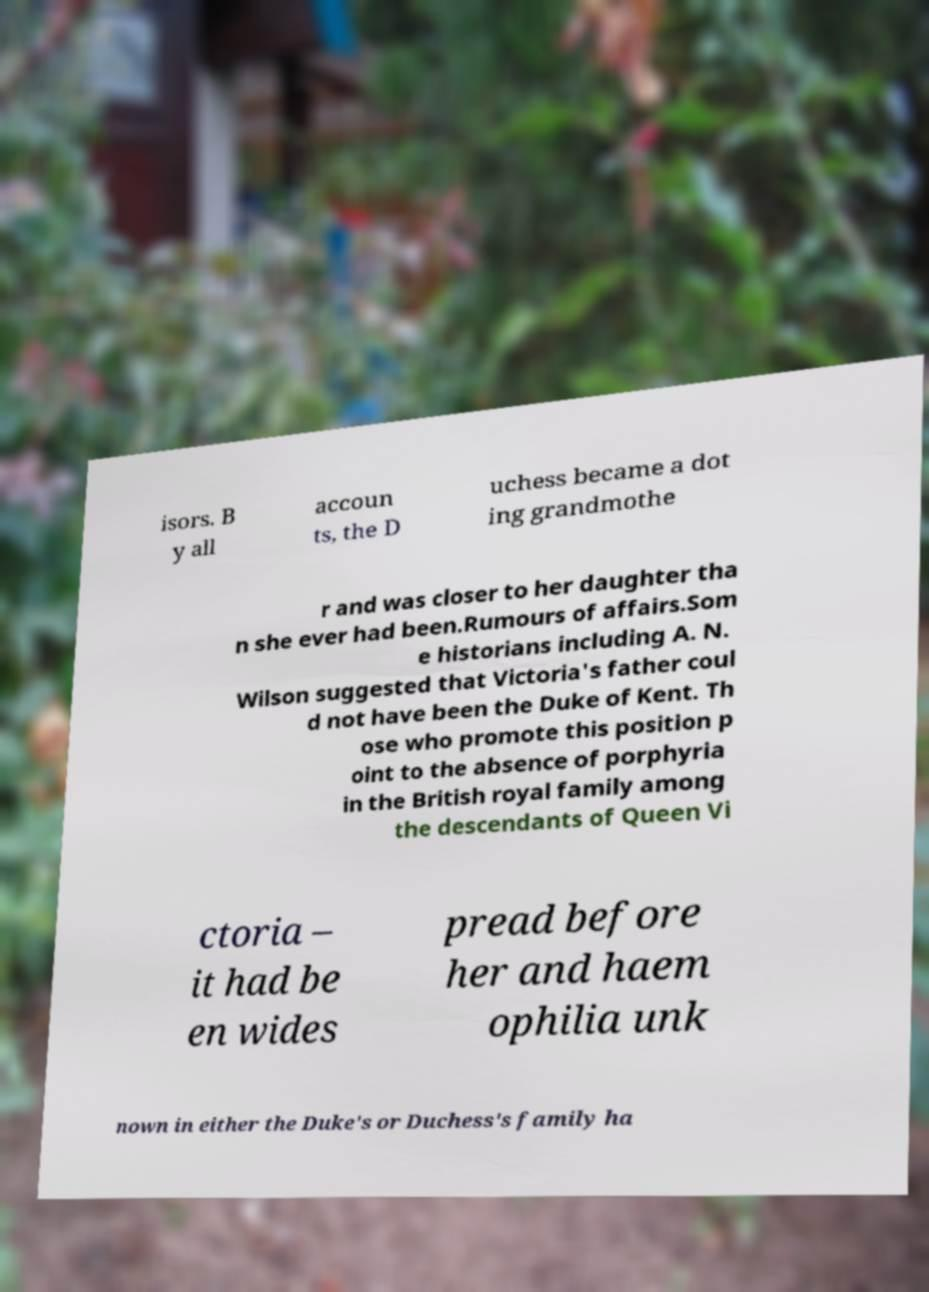What messages or text are displayed in this image? I need them in a readable, typed format. isors. B y all accoun ts, the D uchess became a dot ing grandmothe r and was closer to her daughter tha n she ever had been.Rumours of affairs.Som e historians including A. N. Wilson suggested that Victoria's father coul d not have been the Duke of Kent. Th ose who promote this position p oint to the absence of porphyria in the British royal family among the descendants of Queen Vi ctoria – it had be en wides pread before her and haem ophilia unk nown in either the Duke's or Duchess's family ha 